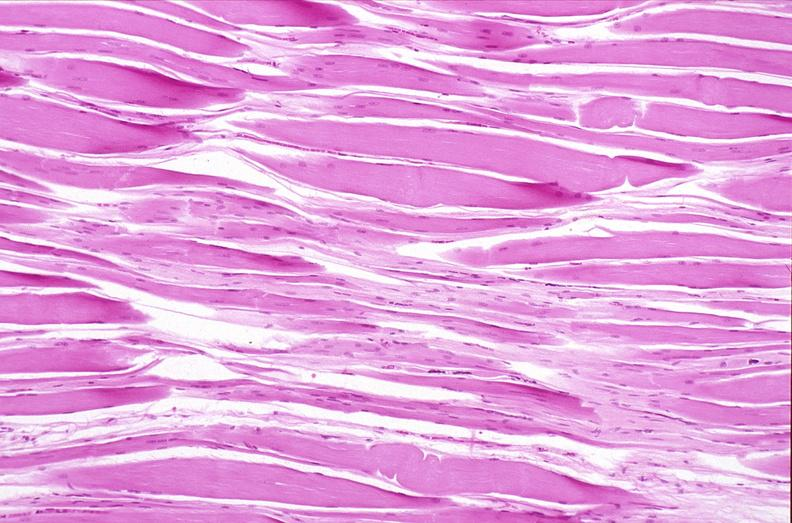what does this image show?
Answer the question using a single word or phrase. Skeletal muscle 